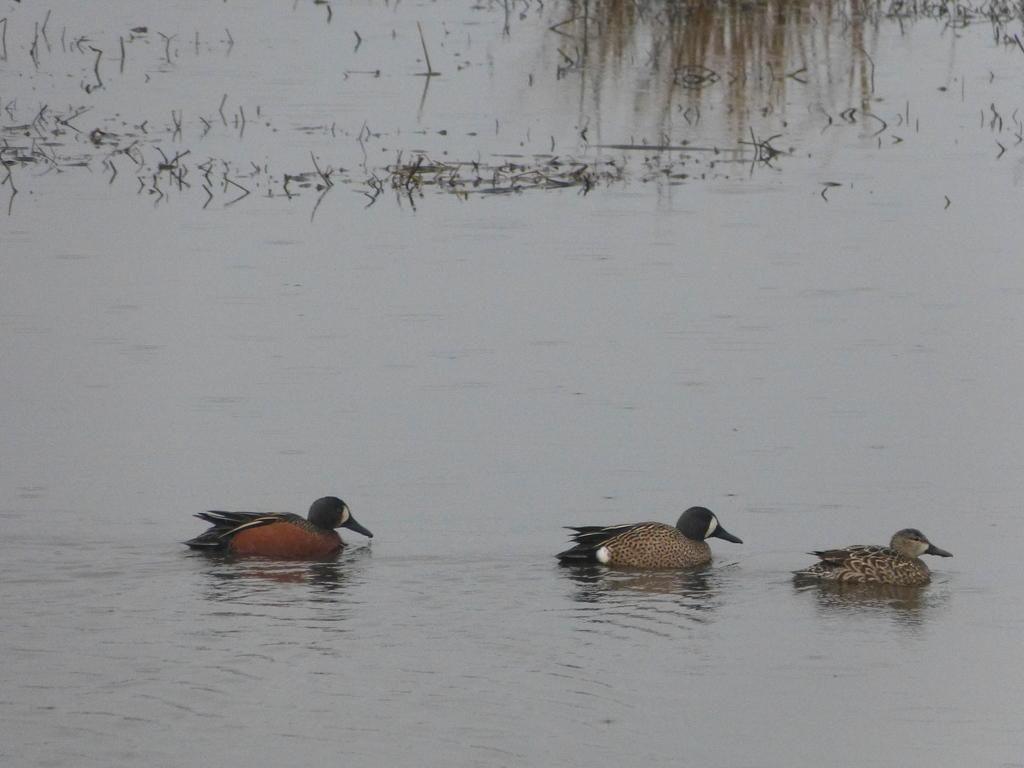What type of animals can be seen in the image? There are ducks in the water. What other elements can be seen in the image besides the ducks? There are plants visible in the image. Is there any vegetation present in the water? Yes, there is grass on the water. What type of truck can be seen driving through the water in the image? There is no truck present in the image; it features ducks in the water and plants. Can you tell me where the iron is located in the image? There is no iron present in the image. 